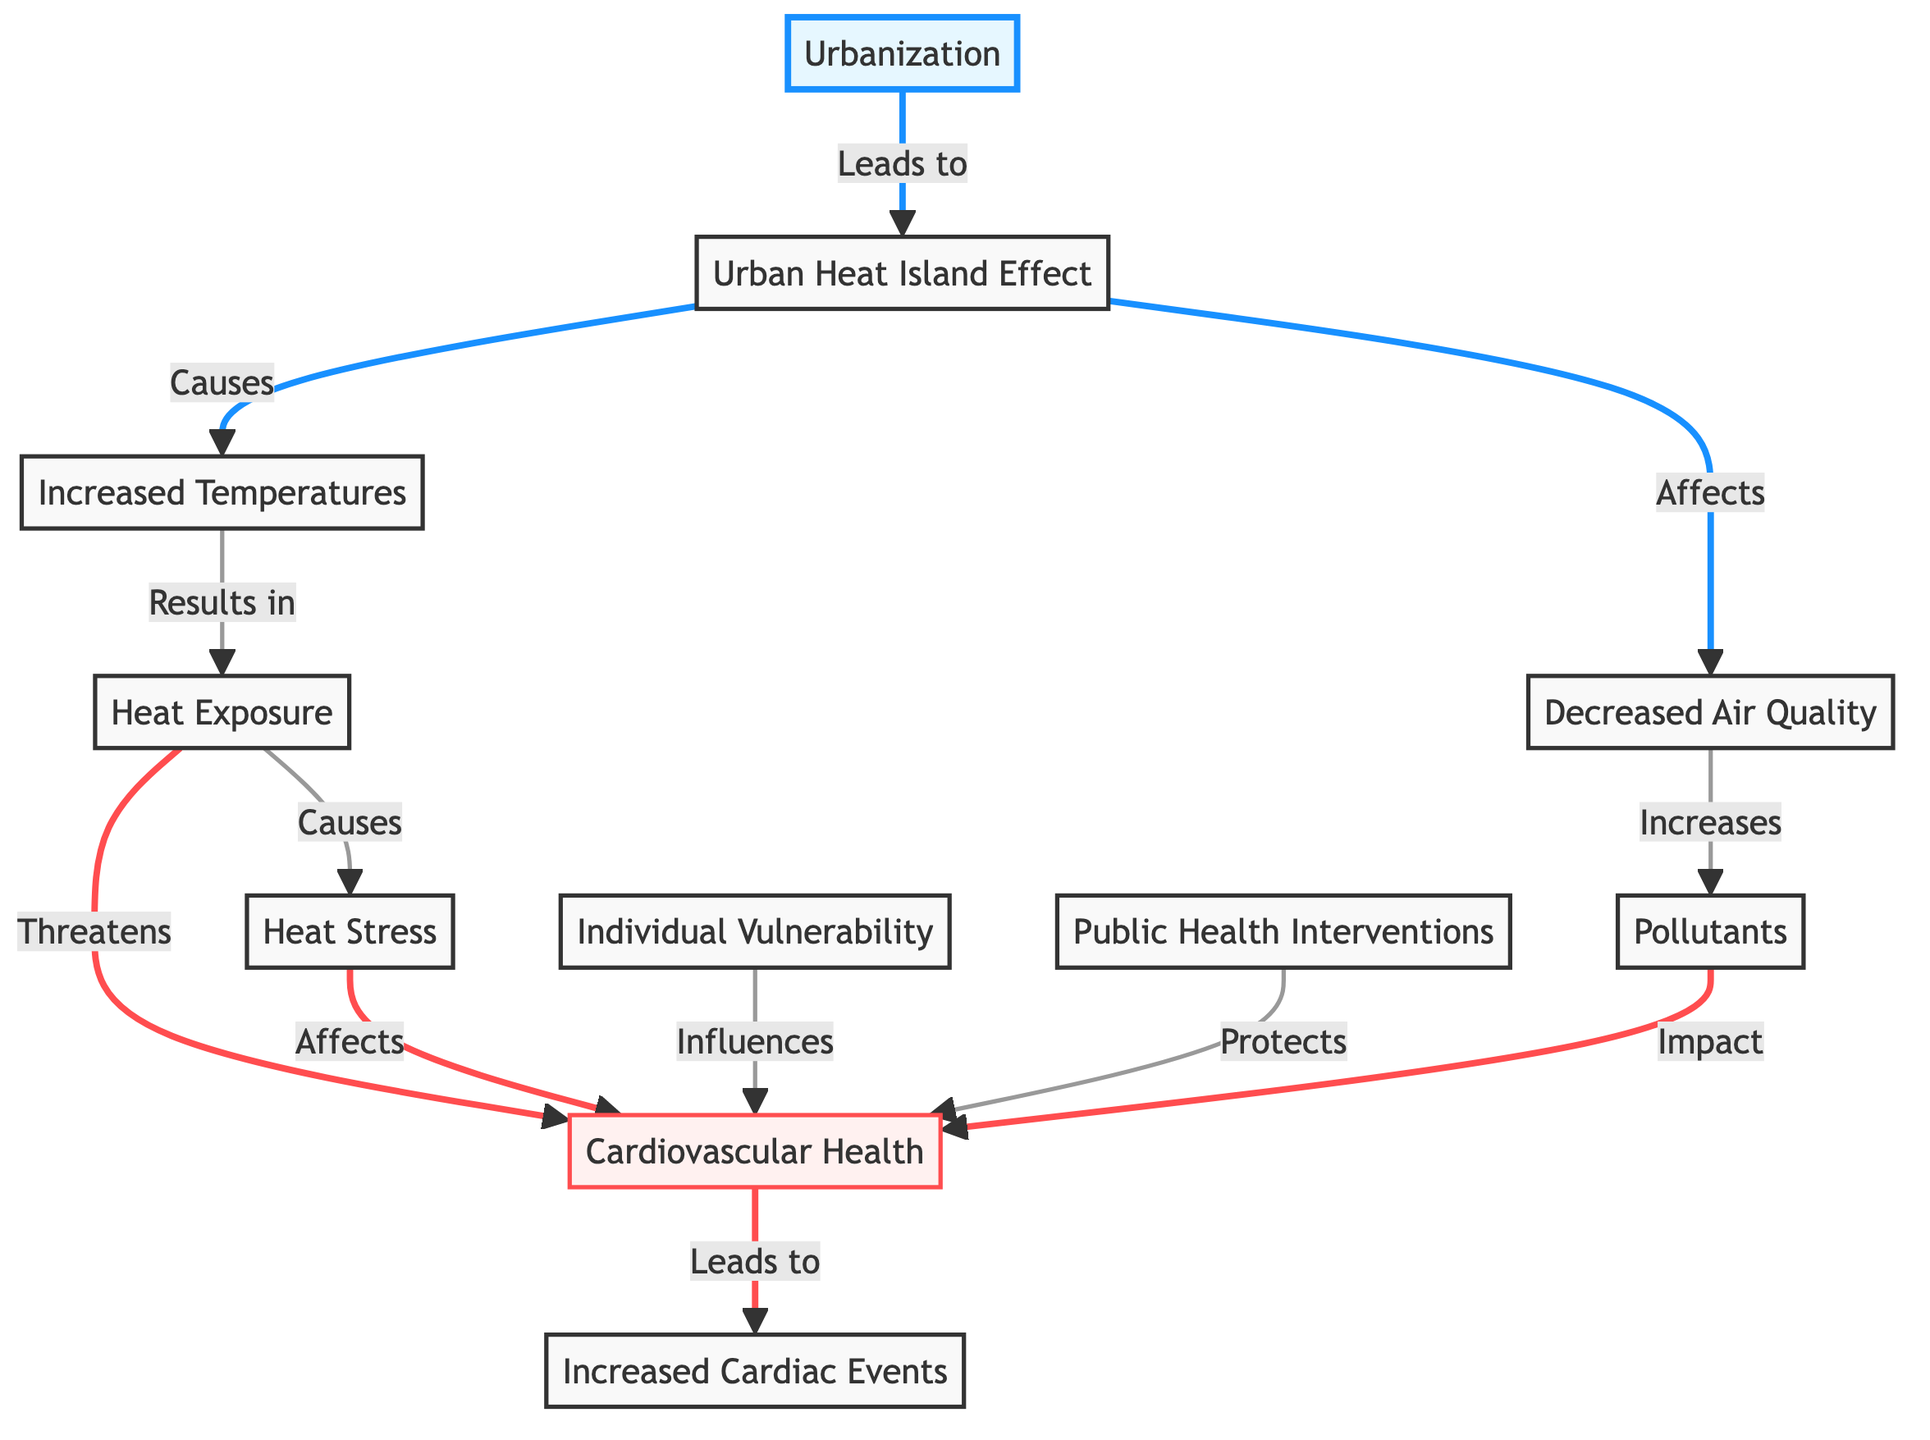What node directly affects air quality? The diagram indicates that the Urban Heat Island Effect directly affects air quality, as represented by the arrow from the Urban Heat Island Effect to the air quality node.
Answer: Urban Heat Island Effect How many impacts are shown on cardiovascular health? By examining the diagram, we can see that there are three distinct arrows leading into the cardiovascular health node: from heat exposure, pollutants, and heat stress. Thus, there are three impacts.
Answer: 3 What leads to increased temperatures? According to the diagram, increased temperatures result from the Urban Heat Island Effect, which is illustrated with a direct arrow.
Answer: Urban Heat Island Effect What is one public health intervention shown in the context of cardiovascular health? While the diagram does not explicitly list specific public health interventions, it shows that public health interventions protect cardiovascular health, indicating their role in addressing health impacts.
Answer: Protects Which nodes are connected by the relationship "results in"? The relationship "results in" connects increased temperatures and heat exposure as illustrated in the diagram, portrayed by the arrow pointing from increased temperatures to heat exposure.
Answer: heat exposure What directly causes cardiac events in the diagram? Upon inspection, the diagram shows that cardiovascular health leads to increased cardiac events, indicating a direct cause-and-effect relationship between these two nodes.
Answer: cardiovascular health What influences cardiovascular health according to the diagram? The diagram indicates that individual vulnerability influences cardiovascular health, with a direct arrow leading from the individual vulnerability node to the cardiovascular health node.
Answer: Individual Vulnerability Which factor is influenced by both increased temperatures and air quality? In the diagram, cardiovascular health is influenced by both increased temperatures (through heat exposure) and air quality (through pollutants). These relationships are shown by arrows leading to the cardiovascular health node.
Answer: cardiovascular health 